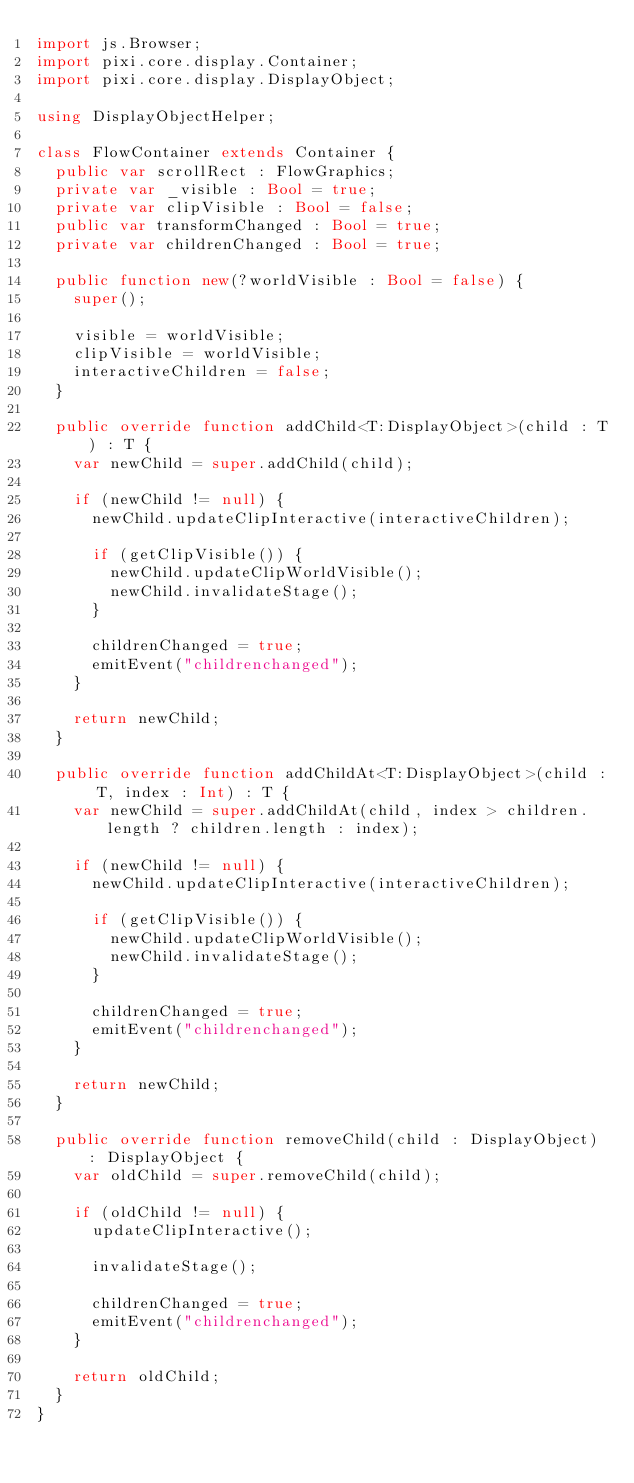Convert code to text. <code><loc_0><loc_0><loc_500><loc_500><_Haxe_>import js.Browser;
import pixi.core.display.Container;
import pixi.core.display.DisplayObject;

using DisplayObjectHelper;

class FlowContainer extends Container {
	public var scrollRect : FlowGraphics;
	private var _visible : Bool = true;
	private var clipVisible : Bool = false;
	public var transformChanged : Bool = true;
	private var childrenChanged : Bool = true;

	public function new(?worldVisible : Bool = false) {
		super();

		visible = worldVisible;
		clipVisible = worldVisible;
		interactiveChildren = false;
	}

	public override function addChild<T:DisplayObject>(child : T) : T {
		var newChild = super.addChild(child);

		if (newChild != null) {
			newChild.updateClipInteractive(interactiveChildren);

			if (getClipVisible()) {
				newChild.updateClipWorldVisible();
				newChild.invalidateStage();
			}

			childrenChanged = true;
			emitEvent("childrenchanged");
		}

		return newChild;
	}

	public override function addChildAt<T:DisplayObject>(child : T, index : Int) : T {
		var newChild = super.addChildAt(child, index > children.length ? children.length : index);

		if (newChild != null) {
			newChild.updateClipInteractive(interactiveChildren);

			if (getClipVisible()) {
				newChild.updateClipWorldVisible();
				newChild.invalidateStage();
			}

			childrenChanged = true;
			emitEvent("childrenchanged");
		}

		return newChild;
	}

	public override function removeChild(child : DisplayObject) : DisplayObject {
		var oldChild = super.removeChild(child);

		if (oldChild != null) {
			updateClipInteractive();

			invalidateStage();

			childrenChanged = true;
			emitEvent("childrenchanged");
		}

		return oldChild;
	}
}</code> 